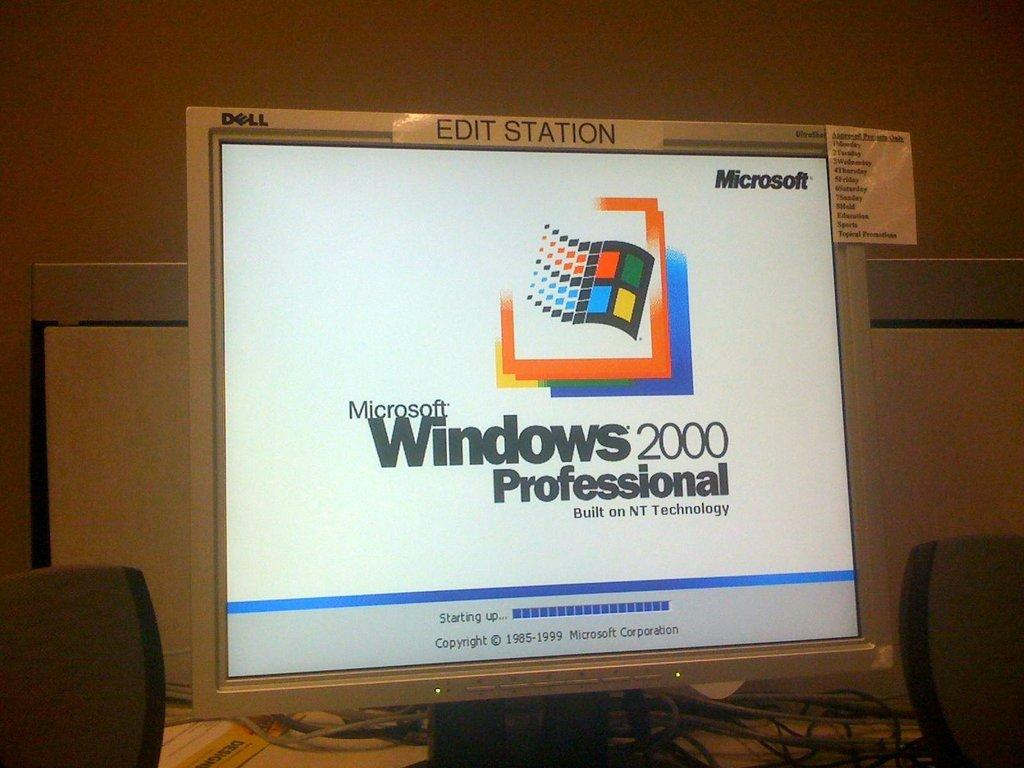<image>
Create a compact narrative representing the image presented. A computer monitor has Windows 2000 Professional on the screen. 